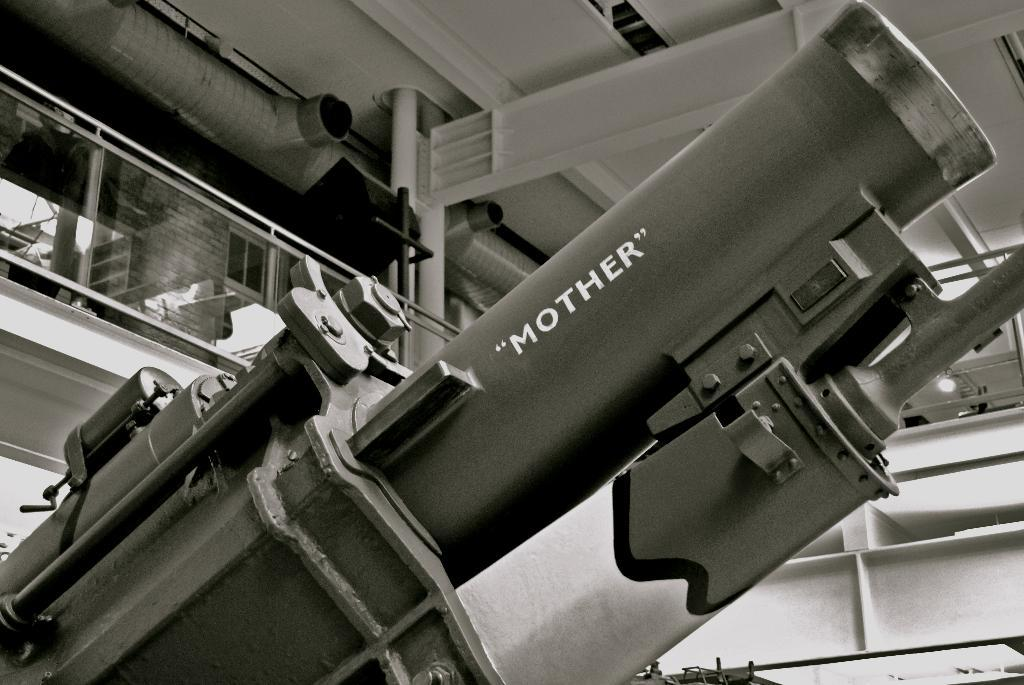What is the main subject of the image? The main subject of the image is a machine. Where is the machine located? The machine is located in a building. What additional information can be gathered from the machine in the image? There is text visible on the machine. What type of picture is hanging on the wall behind the machine in the image? There is no picture hanging on the wall behind the machine in the image. What kind of surprise can be seen in the image? There is no surprise present in the image. 